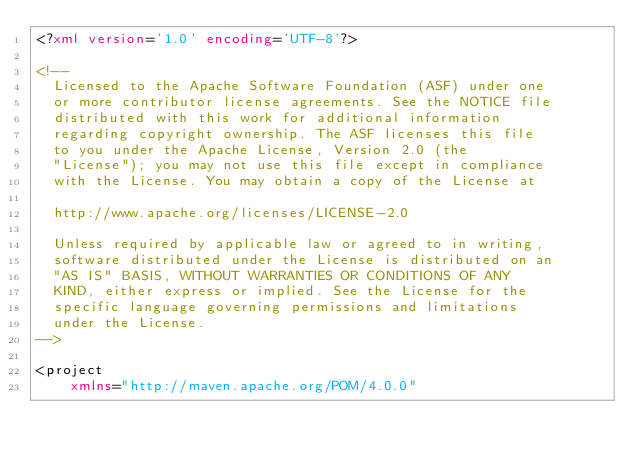<code> <loc_0><loc_0><loc_500><loc_500><_XML_><?xml version='1.0' encoding='UTF-8'?>

<!--
  Licensed to the Apache Software Foundation (ASF) under one
  or more contributor license agreements. See the NOTICE file
  distributed with this work for additional information
  regarding copyright ownership. The ASF licenses this file
  to you under the Apache License, Version 2.0 (the
  "License"); you may not use this file except in compliance
  with the License. You may obtain a copy of the License at

  http://www.apache.org/licenses/LICENSE-2.0

  Unless required by applicable law or agreed to in writing,
  software distributed under the License is distributed on an
  "AS IS" BASIS, WITHOUT WARRANTIES OR CONDITIONS OF ANY
  KIND, either express or implied. See the License for the
  specific language governing permissions and limitations
  under the License.
-->

<project
    xmlns="http://maven.apache.org/POM/4.0.0"</code> 